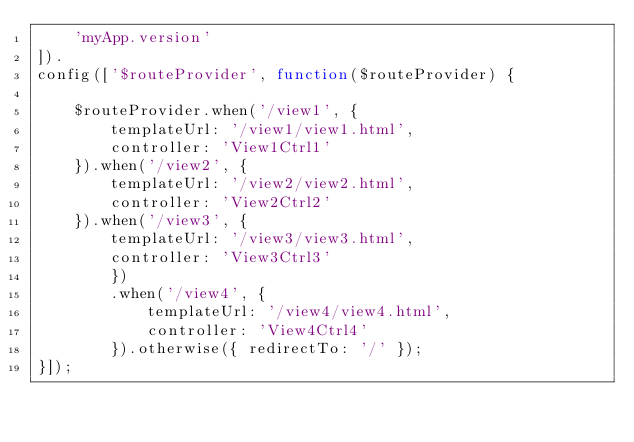Convert code to text. <code><loc_0><loc_0><loc_500><loc_500><_JavaScript_>    'myApp.version'
]).
config(['$routeProvider', function($routeProvider) {

    $routeProvider.when('/view1', {
        templateUrl: '/view1/view1.html',
        controller: 'View1Ctrl1'
    }).when('/view2', {
        templateUrl: '/view2/view2.html',
        controller: 'View2Ctrl2'
    }).when('/view3', {
        templateUrl: '/view3/view3.html',
        controller: 'View3Ctrl3'
        })
        .when('/view4', {
            templateUrl: '/view4/view4.html',
            controller: 'View4Ctrl4'
        }).otherwise({ redirectTo: '/' });
}]);</code> 